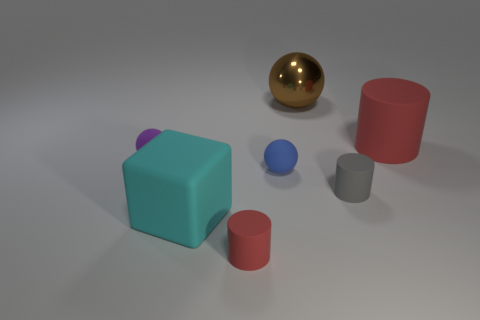Are there any big things behind the small blue matte object? Behind the small blue matte object, there is a large red cylinder and a smaller red cylinder, as well as a larger metallic gold sphere and a medium-sized grey cylinder positioned further back. The spatial arrangement and size of these items in relation to the blue object indeed classify them as 'big' within the context of the image. 